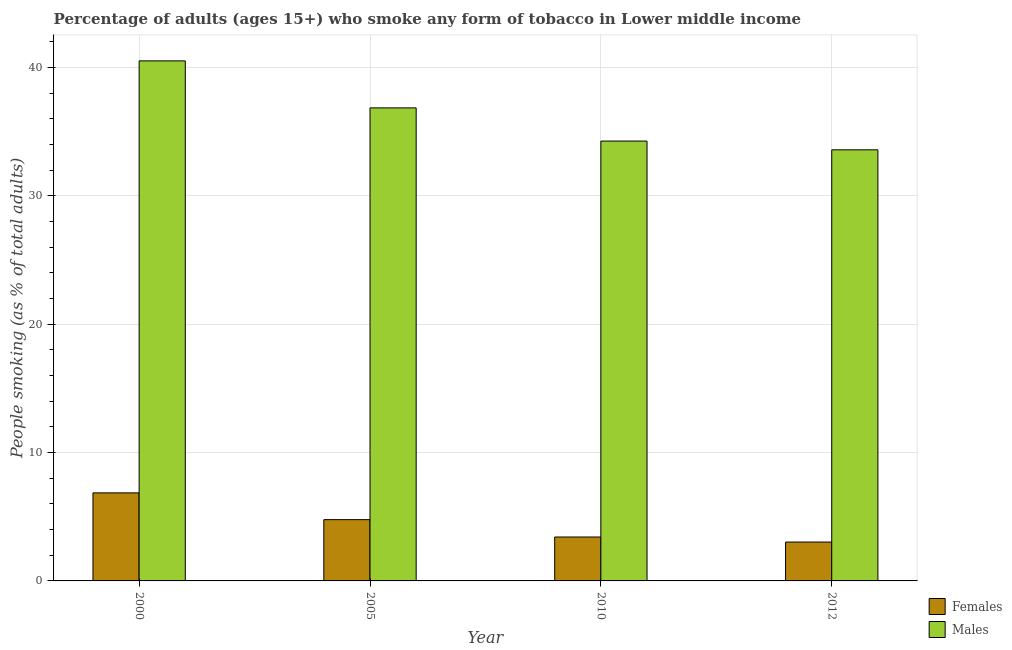How many different coloured bars are there?
Provide a short and direct response. 2. How many groups of bars are there?
Provide a succinct answer. 4. Are the number of bars per tick equal to the number of legend labels?
Provide a succinct answer. Yes. Are the number of bars on each tick of the X-axis equal?
Provide a short and direct response. Yes. How many bars are there on the 4th tick from the left?
Ensure brevity in your answer.  2. What is the label of the 3rd group of bars from the left?
Your answer should be very brief. 2010. In how many cases, is the number of bars for a given year not equal to the number of legend labels?
Provide a short and direct response. 0. What is the percentage of females who smoke in 2012?
Offer a terse response. 3.03. Across all years, what is the maximum percentage of females who smoke?
Your answer should be very brief. 6.86. Across all years, what is the minimum percentage of males who smoke?
Make the answer very short. 33.58. In which year was the percentage of females who smoke maximum?
Your response must be concise. 2000. What is the total percentage of females who smoke in the graph?
Offer a terse response. 18.07. What is the difference between the percentage of males who smoke in 2000 and that in 2012?
Make the answer very short. 6.93. What is the difference between the percentage of females who smoke in 2005 and the percentage of males who smoke in 2000?
Your answer should be compact. -2.08. What is the average percentage of males who smoke per year?
Give a very brief answer. 36.29. In the year 2005, what is the difference between the percentage of females who smoke and percentage of males who smoke?
Your answer should be very brief. 0. In how many years, is the percentage of males who smoke greater than 10 %?
Provide a short and direct response. 4. What is the ratio of the percentage of males who smoke in 2005 to that in 2012?
Offer a very short reply. 1.1. Is the percentage of females who smoke in 2000 less than that in 2005?
Your answer should be compact. No. What is the difference between the highest and the second highest percentage of females who smoke?
Give a very brief answer. 2.08. What is the difference between the highest and the lowest percentage of females who smoke?
Provide a short and direct response. 3.83. What does the 1st bar from the left in 2005 represents?
Make the answer very short. Females. What does the 1st bar from the right in 2012 represents?
Ensure brevity in your answer.  Males. How many bars are there?
Offer a very short reply. 8. Are all the bars in the graph horizontal?
Make the answer very short. No. Are the values on the major ticks of Y-axis written in scientific E-notation?
Offer a very short reply. No. Does the graph contain any zero values?
Offer a very short reply. No. How are the legend labels stacked?
Your answer should be very brief. Vertical. What is the title of the graph?
Keep it short and to the point. Percentage of adults (ages 15+) who smoke any form of tobacco in Lower middle income. What is the label or title of the Y-axis?
Your answer should be very brief. People smoking (as % of total adults). What is the People smoking (as % of total adults) of Females in 2000?
Provide a succinct answer. 6.86. What is the People smoking (as % of total adults) in Males in 2000?
Keep it short and to the point. 40.5. What is the People smoking (as % of total adults) of Females in 2005?
Provide a succinct answer. 4.77. What is the People smoking (as % of total adults) of Males in 2005?
Give a very brief answer. 36.84. What is the People smoking (as % of total adults) of Females in 2010?
Keep it short and to the point. 3.42. What is the People smoking (as % of total adults) of Males in 2010?
Your answer should be very brief. 34.26. What is the People smoking (as % of total adults) of Females in 2012?
Your answer should be very brief. 3.03. What is the People smoking (as % of total adults) of Males in 2012?
Provide a succinct answer. 33.58. Across all years, what is the maximum People smoking (as % of total adults) in Females?
Offer a terse response. 6.86. Across all years, what is the maximum People smoking (as % of total adults) of Males?
Provide a short and direct response. 40.5. Across all years, what is the minimum People smoking (as % of total adults) of Females?
Keep it short and to the point. 3.03. Across all years, what is the minimum People smoking (as % of total adults) of Males?
Your answer should be very brief. 33.58. What is the total People smoking (as % of total adults) in Females in the graph?
Your answer should be compact. 18.07. What is the total People smoking (as % of total adults) in Males in the graph?
Keep it short and to the point. 145.18. What is the difference between the People smoking (as % of total adults) in Females in 2000 and that in 2005?
Keep it short and to the point. 2.08. What is the difference between the People smoking (as % of total adults) in Males in 2000 and that in 2005?
Provide a succinct answer. 3.66. What is the difference between the People smoking (as % of total adults) of Females in 2000 and that in 2010?
Your answer should be very brief. 3.44. What is the difference between the People smoking (as % of total adults) in Males in 2000 and that in 2010?
Provide a short and direct response. 6.25. What is the difference between the People smoking (as % of total adults) of Females in 2000 and that in 2012?
Ensure brevity in your answer.  3.83. What is the difference between the People smoking (as % of total adults) in Males in 2000 and that in 2012?
Offer a very short reply. 6.93. What is the difference between the People smoking (as % of total adults) of Females in 2005 and that in 2010?
Your answer should be compact. 1.35. What is the difference between the People smoking (as % of total adults) in Males in 2005 and that in 2010?
Offer a terse response. 2.59. What is the difference between the People smoking (as % of total adults) in Females in 2005 and that in 2012?
Ensure brevity in your answer.  1.74. What is the difference between the People smoking (as % of total adults) of Males in 2005 and that in 2012?
Provide a short and direct response. 3.27. What is the difference between the People smoking (as % of total adults) in Females in 2010 and that in 2012?
Your answer should be compact. 0.39. What is the difference between the People smoking (as % of total adults) in Males in 2010 and that in 2012?
Your answer should be compact. 0.68. What is the difference between the People smoking (as % of total adults) of Females in 2000 and the People smoking (as % of total adults) of Males in 2005?
Your response must be concise. -29.99. What is the difference between the People smoking (as % of total adults) of Females in 2000 and the People smoking (as % of total adults) of Males in 2010?
Provide a succinct answer. -27.4. What is the difference between the People smoking (as % of total adults) in Females in 2000 and the People smoking (as % of total adults) in Males in 2012?
Offer a very short reply. -26.72. What is the difference between the People smoking (as % of total adults) of Females in 2005 and the People smoking (as % of total adults) of Males in 2010?
Ensure brevity in your answer.  -29.49. What is the difference between the People smoking (as % of total adults) in Females in 2005 and the People smoking (as % of total adults) in Males in 2012?
Keep it short and to the point. -28.8. What is the difference between the People smoking (as % of total adults) of Females in 2010 and the People smoking (as % of total adults) of Males in 2012?
Provide a short and direct response. -30.16. What is the average People smoking (as % of total adults) in Females per year?
Offer a very short reply. 4.52. What is the average People smoking (as % of total adults) in Males per year?
Ensure brevity in your answer.  36.29. In the year 2000, what is the difference between the People smoking (as % of total adults) in Females and People smoking (as % of total adults) in Males?
Offer a terse response. -33.65. In the year 2005, what is the difference between the People smoking (as % of total adults) in Females and People smoking (as % of total adults) in Males?
Your answer should be compact. -32.07. In the year 2010, what is the difference between the People smoking (as % of total adults) of Females and People smoking (as % of total adults) of Males?
Offer a very short reply. -30.84. In the year 2012, what is the difference between the People smoking (as % of total adults) of Females and People smoking (as % of total adults) of Males?
Give a very brief answer. -30.55. What is the ratio of the People smoking (as % of total adults) of Females in 2000 to that in 2005?
Keep it short and to the point. 1.44. What is the ratio of the People smoking (as % of total adults) in Males in 2000 to that in 2005?
Your answer should be compact. 1.1. What is the ratio of the People smoking (as % of total adults) of Females in 2000 to that in 2010?
Offer a very short reply. 2. What is the ratio of the People smoking (as % of total adults) in Males in 2000 to that in 2010?
Give a very brief answer. 1.18. What is the ratio of the People smoking (as % of total adults) of Females in 2000 to that in 2012?
Your answer should be compact. 2.27. What is the ratio of the People smoking (as % of total adults) of Males in 2000 to that in 2012?
Your answer should be very brief. 1.21. What is the ratio of the People smoking (as % of total adults) in Females in 2005 to that in 2010?
Your answer should be very brief. 1.4. What is the ratio of the People smoking (as % of total adults) in Males in 2005 to that in 2010?
Your response must be concise. 1.08. What is the ratio of the People smoking (as % of total adults) of Females in 2005 to that in 2012?
Make the answer very short. 1.58. What is the ratio of the People smoking (as % of total adults) in Males in 2005 to that in 2012?
Provide a succinct answer. 1.1. What is the ratio of the People smoking (as % of total adults) of Females in 2010 to that in 2012?
Offer a terse response. 1.13. What is the ratio of the People smoking (as % of total adults) in Males in 2010 to that in 2012?
Provide a short and direct response. 1.02. What is the difference between the highest and the second highest People smoking (as % of total adults) of Females?
Your response must be concise. 2.08. What is the difference between the highest and the second highest People smoking (as % of total adults) of Males?
Offer a terse response. 3.66. What is the difference between the highest and the lowest People smoking (as % of total adults) of Females?
Your answer should be compact. 3.83. What is the difference between the highest and the lowest People smoking (as % of total adults) of Males?
Give a very brief answer. 6.93. 